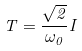<formula> <loc_0><loc_0><loc_500><loc_500>T = \frac { \sqrt { 2 } } { \omega _ { 0 } } I</formula> 